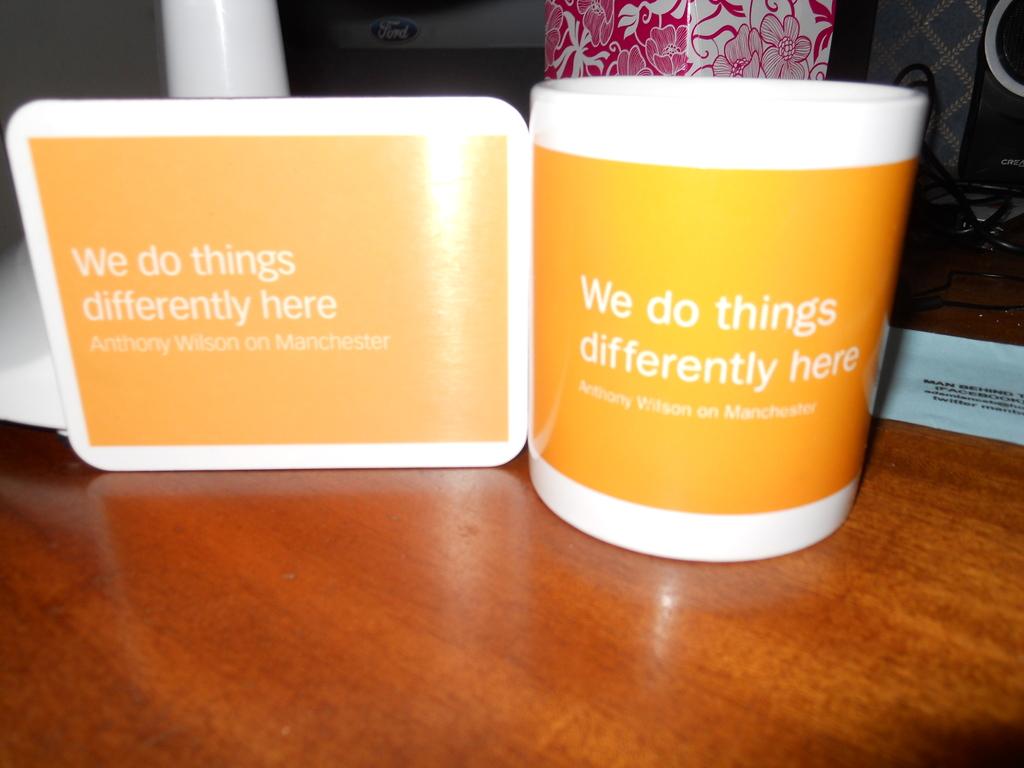Does the slogan on the left match the slogan on the mug?
Give a very brief answer. Yes. 